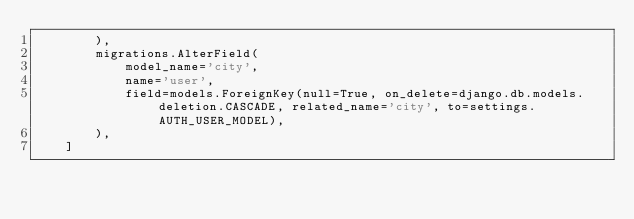Convert code to text. <code><loc_0><loc_0><loc_500><loc_500><_Python_>        ),
        migrations.AlterField(
            model_name='city',
            name='user',
            field=models.ForeignKey(null=True, on_delete=django.db.models.deletion.CASCADE, related_name='city', to=settings.AUTH_USER_MODEL),
        ),
    ]
</code> 